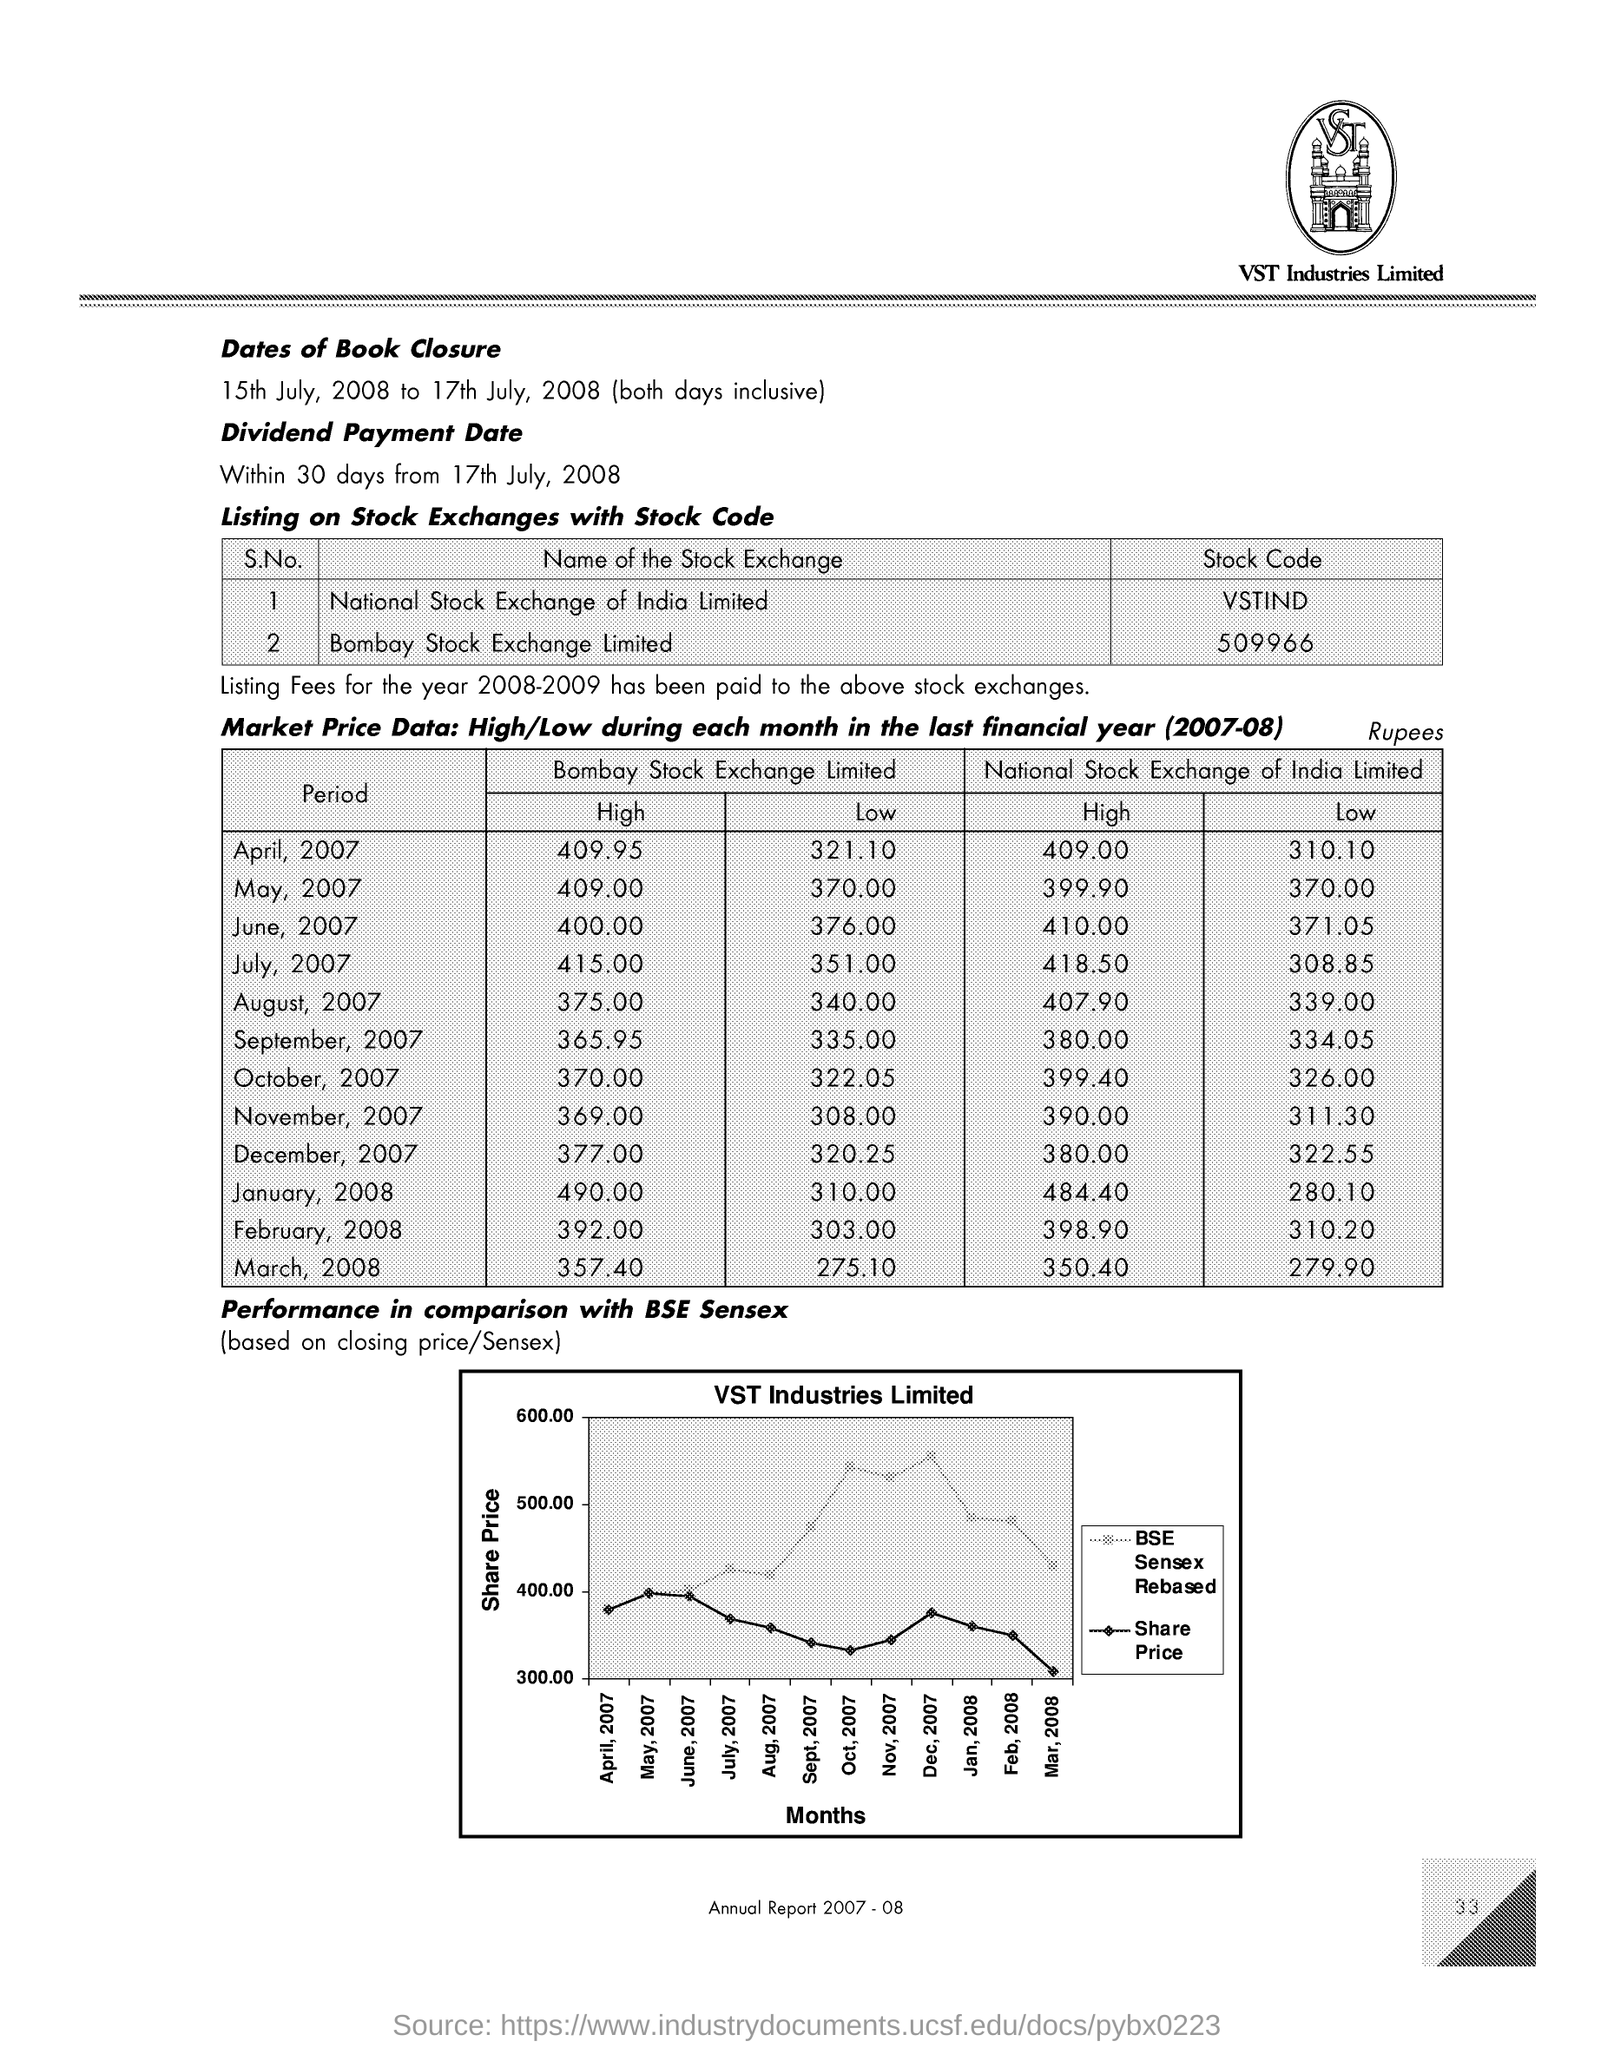Identify some key points in this picture. The dividend payment date is within 30 days from July 17th, 2008. The Bombay Stock Exchange Limited's stock code is 509966... The National Stock Exchange of India Limited has a stock code of VSTIND. The smallest amount of National Stock Exchange of India Limited is 279.90. 